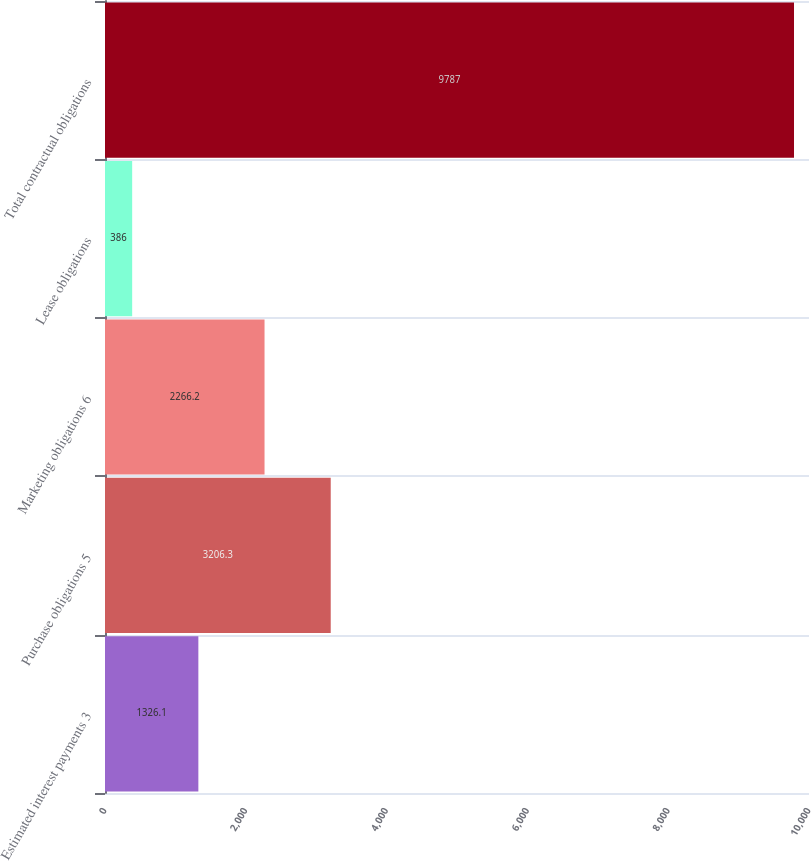<chart> <loc_0><loc_0><loc_500><loc_500><bar_chart><fcel>Estimated interest payments 3<fcel>Purchase obligations 5<fcel>Marketing obligations 6<fcel>Lease obligations<fcel>Total contractual obligations<nl><fcel>1326.1<fcel>3206.3<fcel>2266.2<fcel>386<fcel>9787<nl></chart> 